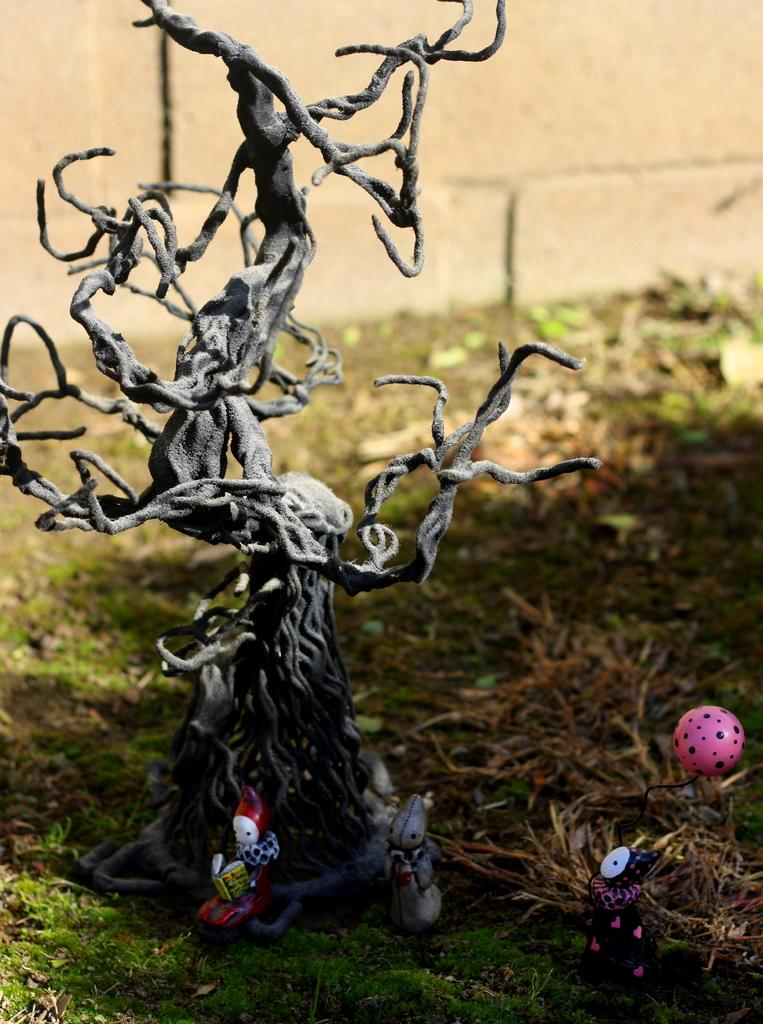What objects are present in the image? There are toys in the image. Where are the toys located? The toys are placed on the grass. What can be seen in the background of the image? There is a wall in the background of the image. What type of pig can be seen in the jar in the image? There is no pig or jar present in the image; it features toys placed on the grass with a wall in the background. 